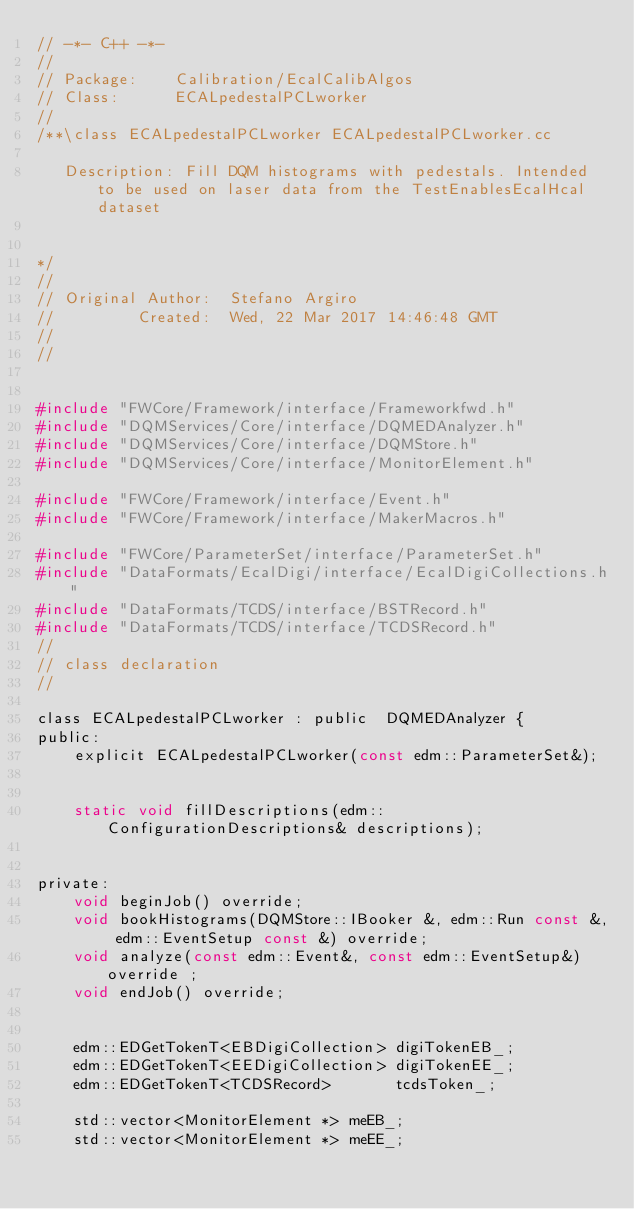Convert code to text. <code><loc_0><loc_0><loc_500><loc_500><_C_>// -*- C++ -*-
//
// Package:    Calibration/EcalCalibAlgos
// Class:      ECALpedestalPCLworker
// 
/**\class ECALpedestalPCLworker ECALpedestalPCLworker.cc 

   Description: Fill DQM histograms with pedestals. Intended to be used on laser data from the TestEnablesEcalHcal dataset

 
*/
//
// Original Author:  Stefano Argiro
//         Created:  Wed, 22 Mar 2017 14:46:48 GMT
//
//


#include "FWCore/Framework/interface/Frameworkfwd.h"
#include "DQMServices/Core/interface/DQMEDAnalyzer.h"
#include "DQMServices/Core/interface/DQMStore.h"
#include "DQMServices/Core/interface/MonitorElement.h"

#include "FWCore/Framework/interface/Event.h"
#include "FWCore/Framework/interface/MakerMacros.h"

#include "FWCore/ParameterSet/interface/ParameterSet.h"
#include "DataFormats/EcalDigi/interface/EcalDigiCollections.h"
#include "DataFormats/TCDS/interface/BSTRecord.h"
#include "DataFormats/TCDS/interface/TCDSRecord.h"
//
// class declaration
//

class ECALpedestalPCLworker : public  DQMEDAnalyzer {
public:
    explicit ECALpedestalPCLworker(const edm::ParameterSet&);
     

    static void fillDescriptions(edm::ConfigurationDescriptions& descriptions);


private:
    void beginJob() override;
    void bookHistograms(DQMStore::IBooker &, edm::Run const &, edm::EventSetup const &) override;   
    void analyze(const edm::Event&, const edm::EventSetup&) override ;
    void endJob() override;


    edm::EDGetTokenT<EBDigiCollection> digiTokenEB_; 
    edm::EDGetTokenT<EEDigiCollection> digiTokenEE_; 
    edm::EDGetTokenT<TCDSRecord>       tcdsToken_; 

    std::vector<MonitorElement *> meEB_;
    std::vector<MonitorElement *> meEE_;
</code> 